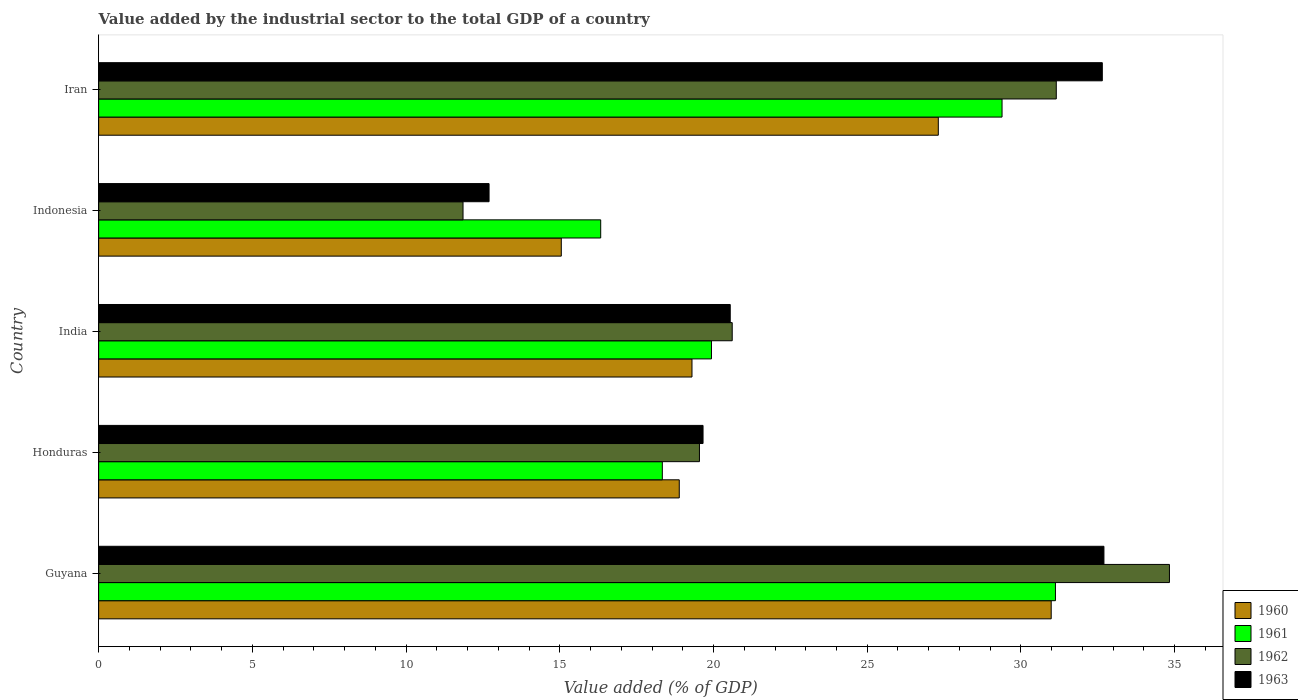How many groups of bars are there?
Ensure brevity in your answer.  5. How many bars are there on the 1st tick from the top?
Give a very brief answer. 4. How many bars are there on the 3rd tick from the bottom?
Keep it short and to the point. 4. What is the label of the 5th group of bars from the top?
Keep it short and to the point. Guyana. In how many cases, is the number of bars for a given country not equal to the number of legend labels?
Keep it short and to the point. 0. What is the value added by the industrial sector to the total GDP in 1960 in Indonesia?
Provide a short and direct response. 15.05. Across all countries, what is the maximum value added by the industrial sector to the total GDP in 1963?
Your answer should be compact. 32.7. Across all countries, what is the minimum value added by the industrial sector to the total GDP in 1960?
Ensure brevity in your answer.  15.05. In which country was the value added by the industrial sector to the total GDP in 1960 maximum?
Keep it short and to the point. Guyana. In which country was the value added by the industrial sector to the total GDP in 1963 minimum?
Make the answer very short. Indonesia. What is the total value added by the industrial sector to the total GDP in 1961 in the graph?
Keep it short and to the point. 115.11. What is the difference between the value added by the industrial sector to the total GDP in 1961 in Guyana and that in Iran?
Ensure brevity in your answer.  1.74. What is the difference between the value added by the industrial sector to the total GDP in 1960 in Honduras and the value added by the industrial sector to the total GDP in 1961 in Iran?
Make the answer very short. -10.5. What is the average value added by the industrial sector to the total GDP in 1963 per country?
Your answer should be compact. 23.65. What is the difference between the value added by the industrial sector to the total GDP in 1962 and value added by the industrial sector to the total GDP in 1960 in Indonesia?
Your response must be concise. -3.2. In how many countries, is the value added by the industrial sector to the total GDP in 1962 greater than 6 %?
Give a very brief answer. 5. What is the ratio of the value added by the industrial sector to the total GDP in 1963 in Honduras to that in India?
Your response must be concise. 0.96. Is the value added by the industrial sector to the total GDP in 1962 in Guyana less than that in Iran?
Ensure brevity in your answer.  No. What is the difference between the highest and the second highest value added by the industrial sector to the total GDP in 1963?
Offer a terse response. 0.05. What is the difference between the highest and the lowest value added by the industrial sector to the total GDP in 1961?
Offer a terse response. 14.79. Is it the case that in every country, the sum of the value added by the industrial sector to the total GDP in 1960 and value added by the industrial sector to the total GDP in 1963 is greater than the sum of value added by the industrial sector to the total GDP in 1962 and value added by the industrial sector to the total GDP in 1961?
Your answer should be very brief. No. What does the 1st bar from the bottom in Indonesia represents?
Offer a terse response. 1960. Is it the case that in every country, the sum of the value added by the industrial sector to the total GDP in 1962 and value added by the industrial sector to the total GDP in 1961 is greater than the value added by the industrial sector to the total GDP in 1963?
Ensure brevity in your answer.  Yes. Are all the bars in the graph horizontal?
Provide a short and direct response. Yes. How many countries are there in the graph?
Offer a terse response. 5. How many legend labels are there?
Keep it short and to the point. 4. What is the title of the graph?
Ensure brevity in your answer.  Value added by the industrial sector to the total GDP of a country. Does "1968" appear as one of the legend labels in the graph?
Your response must be concise. No. What is the label or title of the X-axis?
Your response must be concise. Value added (% of GDP). What is the label or title of the Y-axis?
Ensure brevity in your answer.  Country. What is the Value added (% of GDP) of 1960 in Guyana?
Your answer should be compact. 30.98. What is the Value added (% of GDP) of 1961 in Guyana?
Your response must be concise. 31.12. What is the Value added (% of GDP) of 1962 in Guyana?
Your response must be concise. 34.83. What is the Value added (% of GDP) of 1963 in Guyana?
Offer a terse response. 32.7. What is the Value added (% of GDP) in 1960 in Honduras?
Give a very brief answer. 18.89. What is the Value added (% of GDP) of 1961 in Honduras?
Your answer should be very brief. 18.33. What is the Value added (% of GDP) of 1962 in Honduras?
Make the answer very short. 19.54. What is the Value added (% of GDP) of 1963 in Honduras?
Your answer should be compact. 19.66. What is the Value added (% of GDP) of 1960 in India?
Provide a short and direct response. 19.3. What is the Value added (% of GDP) in 1961 in India?
Your response must be concise. 19.93. What is the Value added (% of GDP) in 1962 in India?
Ensure brevity in your answer.  20.61. What is the Value added (% of GDP) of 1963 in India?
Offer a very short reply. 20.54. What is the Value added (% of GDP) of 1960 in Indonesia?
Provide a succinct answer. 15.05. What is the Value added (% of GDP) of 1961 in Indonesia?
Offer a terse response. 16.33. What is the Value added (% of GDP) of 1962 in Indonesia?
Offer a very short reply. 11.85. What is the Value added (% of GDP) in 1963 in Indonesia?
Your response must be concise. 12.7. What is the Value added (% of GDP) in 1960 in Iran?
Provide a short and direct response. 27.31. What is the Value added (% of GDP) in 1961 in Iran?
Provide a short and direct response. 29.38. What is the Value added (% of GDP) of 1962 in Iran?
Ensure brevity in your answer.  31.15. What is the Value added (% of GDP) of 1963 in Iran?
Provide a succinct answer. 32.65. Across all countries, what is the maximum Value added (% of GDP) in 1960?
Provide a short and direct response. 30.98. Across all countries, what is the maximum Value added (% of GDP) of 1961?
Your answer should be compact. 31.12. Across all countries, what is the maximum Value added (% of GDP) in 1962?
Your response must be concise. 34.83. Across all countries, what is the maximum Value added (% of GDP) of 1963?
Provide a short and direct response. 32.7. Across all countries, what is the minimum Value added (% of GDP) of 1960?
Provide a succinct answer. 15.05. Across all countries, what is the minimum Value added (% of GDP) of 1961?
Make the answer very short. 16.33. Across all countries, what is the minimum Value added (% of GDP) in 1962?
Make the answer very short. 11.85. Across all countries, what is the minimum Value added (% of GDP) in 1963?
Provide a succinct answer. 12.7. What is the total Value added (% of GDP) in 1960 in the graph?
Keep it short and to the point. 111.53. What is the total Value added (% of GDP) of 1961 in the graph?
Your answer should be very brief. 115.11. What is the total Value added (% of GDP) in 1962 in the graph?
Provide a short and direct response. 117.98. What is the total Value added (% of GDP) of 1963 in the graph?
Your response must be concise. 118.25. What is the difference between the Value added (% of GDP) in 1960 in Guyana and that in Honduras?
Your answer should be very brief. 12.1. What is the difference between the Value added (% of GDP) in 1961 in Guyana and that in Honduras?
Your answer should be compact. 12.79. What is the difference between the Value added (% of GDP) of 1962 in Guyana and that in Honduras?
Keep it short and to the point. 15.29. What is the difference between the Value added (% of GDP) in 1963 in Guyana and that in Honduras?
Provide a short and direct response. 13.04. What is the difference between the Value added (% of GDP) in 1960 in Guyana and that in India?
Offer a terse response. 11.68. What is the difference between the Value added (% of GDP) in 1961 in Guyana and that in India?
Offer a terse response. 11.19. What is the difference between the Value added (% of GDP) of 1962 in Guyana and that in India?
Keep it short and to the point. 14.22. What is the difference between the Value added (% of GDP) in 1963 in Guyana and that in India?
Your answer should be very brief. 12.15. What is the difference between the Value added (% of GDP) in 1960 in Guyana and that in Indonesia?
Offer a terse response. 15.93. What is the difference between the Value added (% of GDP) in 1961 in Guyana and that in Indonesia?
Offer a very short reply. 14.79. What is the difference between the Value added (% of GDP) in 1962 in Guyana and that in Indonesia?
Your answer should be very brief. 22.98. What is the difference between the Value added (% of GDP) in 1963 in Guyana and that in Indonesia?
Provide a short and direct response. 20. What is the difference between the Value added (% of GDP) in 1960 in Guyana and that in Iran?
Ensure brevity in your answer.  3.67. What is the difference between the Value added (% of GDP) of 1961 in Guyana and that in Iran?
Give a very brief answer. 1.74. What is the difference between the Value added (% of GDP) in 1962 in Guyana and that in Iran?
Your response must be concise. 3.68. What is the difference between the Value added (% of GDP) in 1963 in Guyana and that in Iran?
Provide a short and direct response. 0.05. What is the difference between the Value added (% of GDP) of 1960 in Honduras and that in India?
Make the answer very short. -0.41. What is the difference between the Value added (% of GDP) of 1961 in Honduras and that in India?
Offer a very short reply. -1.6. What is the difference between the Value added (% of GDP) in 1962 in Honduras and that in India?
Your response must be concise. -1.07. What is the difference between the Value added (% of GDP) of 1963 in Honduras and that in India?
Your answer should be very brief. -0.88. What is the difference between the Value added (% of GDP) of 1960 in Honduras and that in Indonesia?
Make the answer very short. 3.84. What is the difference between the Value added (% of GDP) of 1961 in Honduras and that in Indonesia?
Provide a succinct answer. 2. What is the difference between the Value added (% of GDP) in 1962 in Honduras and that in Indonesia?
Make the answer very short. 7.69. What is the difference between the Value added (% of GDP) in 1963 in Honduras and that in Indonesia?
Provide a short and direct response. 6.96. What is the difference between the Value added (% of GDP) of 1960 in Honduras and that in Iran?
Offer a very short reply. -8.43. What is the difference between the Value added (% of GDP) of 1961 in Honduras and that in Iran?
Your answer should be very brief. -11.05. What is the difference between the Value added (% of GDP) of 1962 in Honduras and that in Iran?
Your answer should be compact. -11.61. What is the difference between the Value added (% of GDP) of 1963 in Honduras and that in Iran?
Offer a terse response. -12.99. What is the difference between the Value added (% of GDP) of 1960 in India and that in Indonesia?
Offer a very short reply. 4.25. What is the difference between the Value added (% of GDP) of 1961 in India and that in Indonesia?
Keep it short and to the point. 3.6. What is the difference between the Value added (% of GDP) in 1962 in India and that in Indonesia?
Offer a terse response. 8.76. What is the difference between the Value added (% of GDP) in 1963 in India and that in Indonesia?
Give a very brief answer. 7.84. What is the difference between the Value added (% of GDP) of 1960 in India and that in Iran?
Make the answer very short. -8.01. What is the difference between the Value added (% of GDP) in 1961 in India and that in Iran?
Your answer should be very brief. -9.45. What is the difference between the Value added (% of GDP) in 1962 in India and that in Iran?
Your answer should be very brief. -10.54. What is the difference between the Value added (% of GDP) of 1963 in India and that in Iran?
Provide a succinct answer. -12.1. What is the difference between the Value added (% of GDP) of 1960 in Indonesia and that in Iran?
Keep it short and to the point. -12.26. What is the difference between the Value added (% of GDP) in 1961 in Indonesia and that in Iran?
Ensure brevity in your answer.  -13.05. What is the difference between the Value added (% of GDP) in 1962 in Indonesia and that in Iran?
Your response must be concise. -19.3. What is the difference between the Value added (% of GDP) in 1963 in Indonesia and that in Iran?
Provide a succinct answer. -19.95. What is the difference between the Value added (% of GDP) of 1960 in Guyana and the Value added (% of GDP) of 1961 in Honduras?
Keep it short and to the point. 12.65. What is the difference between the Value added (% of GDP) of 1960 in Guyana and the Value added (% of GDP) of 1962 in Honduras?
Your answer should be very brief. 11.44. What is the difference between the Value added (% of GDP) of 1960 in Guyana and the Value added (% of GDP) of 1963 in Honduras?
Provide a short and direct response. 11.32. What is the difference between the Value added (% of GDP) in 1961 in Guyana and the Value added (% of GDP) in 1962 in Honduras?
Offer a very short reply. 11.58. What is the difference between the Value added (% of GDP) in 1961 in Guyana and the Value added (% of GDP) in 1963 in Honduras?
Your response must be concise. 11.46. What is the difference between the Value added (% of GDP) of 1962 in Guyana and the Value added (% of GDP) of 1963 in Honduras?
Give a very brief answer. 15.17. What is the difference between the Value added (% of GDP) of 1960 in Guyana and the Value added (% of GDP) of 1961 in India?
Your answer should be compact. 11.05. What is the difference between the Value added (% of GDP) of 1960 in Guyana and the Value added (% of GDP) of 1962 in India?
Ensure brevity in your answer.  10.37. What is the difference between the Value added (% of GDP) of 1960 in Guyana and the Value added (% of GDP) of 1963 in India?
Your response must be concise. 10.44. What is the difference between the Value added (% of GDP) of 1961 in Guyana and the Value added (% of GDP) of 1962 in India?
Give a very brief answer. 10.51. What is the difference between the Value added (% of GDP) of 1961 in Guyana and the Value added (% of GDP) of 1963 in India?
Provide a short and direct response. 10.58. What is the difference between the Value added (% of GDP) in 1962 in Guyana and the Value added (% of GDP) in 1963 in India?
Your answer should be very brief. 14.29. What is the difference between the Value added (% of GDP) in 1960 in Guyana and the Value added (% of GDP) in 1961 in Indonesia?
Provide a succinct answer. 14.65. What is the difference between the Value added (% of GDP) in 1960 in Guyana and the Value added (% of GDP) in 1962 in Indonesia?
Provide a succinct answer. 19.13. What is the difference between the Value added (% of GDP) of 1960 in Guyana and the Value added (% of GDP) of 1963 in Indonesia?
Your answer should be very brief. 18.28. What is the difference between the Value added (% of GDP) in 1961 in Guyana and the Value added (% of GDP) in 1962 in Indonesia?
Ensure brevity in your answer.  19.27. What is the difference between the Value added (% of GDP) in 1961 in Guyana and the Value added (% of GDP) in 1963 in Indonesia?
Give a very brief answer. 18.42. What is the difference between the Value added (% of GDP) of 1962 in Guyana and the Value added (% of GDP) of 1963 in Indonesia?
Your answer should be very brief. 22.13. What is the difference between the Value added (% of GDP) of 1960 in Guyana and the Value added (% of GDP) of 1961 in Iran?
Give a very brief answer. 1.6. What is the difference between the Value added (% of GDP) in 1960 in Guyana and the Value added (% of GDP) in 1962 in Iran?
Provide a succinct answer. -0.17. What is the difference between the Value added (% of GDP) in 1960 in Guyana and the Value added (% of GDP) in 1963 in Iran?
Ensure brevity in your answer.  -1.66. What is the difference between the Value added (% of GDP) of 1961 in Guyana and the Value added (% of GDP) of 1962 in Iran?
Provide a succinct answer. -0.03. What is the difference between the Value added (% of GDP) in 1961 in Guyana and the Value added (% of GDP) in 1963 in Iran?
Provide a short and direct response. -1.52. What is the difference between the Value added (% of GDP) of 1962 in Guyana and the Value added (% of GDP) of 1963 in Iran?
Ensure brevity in your answer.  2.18. What is the difference between the Value added (% of GDP) of 1960 in Honduras and the Value added (% of GDP) of 1961 in India?
Offer a terse response. -1.05. What is the difference between the Value added (% of GDP) of 1960 in Honduras and the Value added (% of GDP) of 1962 in India?
Make the answer very short. -1.72. What is the difference between the Value added (% of GDP) in 1960 in Honduras and the Value added (% of GDP) in 1963 in India?
Keep it short and to the point. -1.66. What is the difference between the Value added (% of GDP) of 1961 in Honduras and the Value added (% of GDP) of 1962 in India?
Offer a very short reply. -2.27. What is the difference between the Value added (% of GDP) of 1961 in Honduras and the Value added (% of GDP) of 1963 in India?
Provide a succinct answer. -2.21. What is the difference between the Value added (% of GDP) of 1962 in Honduras and the Value added (% of GDP) of 1963 in India?
Provide a succinct answer. -1. What is the difference between the Value added (% of GDP) in 1960 in Honduras and the Value added (% of GDP) in 1961 in Indonesia?
Provide a short and direct response. 2.56. What is the difference between the Value added (% of GDP) in 1960 in Honduras and the Value added (% of GDP) in 1962 in Indonesia?
Your answer should be compact. 7.03. What is the difference between the Value added (% of GDP) of 1960 in Honduras and the Value added (% of GDP) of 1963 in Indonesia?
Provide a succinct answer. 6.19. What is the difference between the Value added (% of GDP) in 1961 in Honduras and the Value added (% of GDP) in 1962 in Indonesia?
Keep it short and to the point. 6.48. What is the difference between the Value added (% of GDP) of 1961 in Honduras and the Value added (% of GDP) of 1963 in Indonesia?
Keep it short and to the point. 5.64. What is the difference between the Value added (% of GDP) in 1962 in Honduras and the Value added (% of GDP) in 1963 in Indonesia?
Provide a succinct answer. 6.84. What is the difference between the Value added (% of GDP) in 1960 in Honduras and the Value added (% of GDP) in 1961 in Iran?
Keep it short and to the point. -10.5. What is the difference between the Value added (% of GDP) of 1960 in Honduras and the Value added (% of GDP) of 1962 in Iran?
Provide a succinct answer. -12.26. What is the difference between the Value added (% of GDP) in 1960 in Honduras and the Value added (% of GDP) in 1963 in Iran?
Provide a short and direct response. -13.76. What is the difference between the Value added (% of GDP) in 1961 in Honduras and the Value added (% of GDP) in 1962 in Iran?
Provide a short and direct response. -12.81. What is the difference between the Value added (% of GDP) in 1961 in Honduras and the Value added (% of GDP) in 1963 in Iran?
Your response must be concise. -14.31. What is the difference between the Value added (% of GDP) of 1962 in Honduras and the Value added (% of GDP) of 1963 in Iran?
Make the answer very short. -13.1. What is the difference between the Value added (% of GDP) in 1960 in India and the Value added (% of GDP) in 1961 in Indonesia?
Offer a terse response. 2.97. What is the difference between the Value added (% of GDP) of 1960 in India and the Value added (% of GDP) of 1962 in Indonesia?
Your answer should be compact. 7.45. What is the difference between the Value added (% of GDP) in 1960 in India and the Value added (% of GDP) in 1963 in Indonesia?
Provide a short and direct response. 6.6. What is the difference between the Value added (% of GDP) in 1961 in India and the Value added (% of GDP) in 1962 in Indonesia?
Your response must be concise. 8.08. What is the difference between the Value added (% of GDP) in 1961 in India and the Value added (% of GDP) in 1963 in Indonesia?
Give a very brief answer. 7.23. What is the difference between the Value added (% of GDP) in 1962 in India and the Value added (% of GDP) in 1963 in Indonesia?
Offer a very short reply. 7.91. What is the difference between the Value added (% of GDP) in 1960 in India and the Value added (% of GDP) in 1961 in Iran?
Your response must be concise. -10.09. What is the difference between the Value added (% of GDP) in 1960 in India and the Value added (% of GDP) in 1962 in Iran?
Your response must be concise. -11.85. What is the difference between the Value added (% of GDP) of 1960 in India and the Value added (% of GDP) of 1963 in Iran?
Your answer should be very brief. -13.35. What is the difference between the Value added (% of GDP) of 1961 in India and the Value added (% of GDP) of 1962 in Iran?
Ensure brevity in your answer.  -11.22. What is the difference between the Value added (% of GDP) of 1961 in India and the Value added (% of GDP) of 1963 in Iran?
Your answer should be very brief. -12.71. What is the difference between the Value added (% of GDP) in 1962 in India and the Value added (% of GDP) in 1963 in Iran?
Your response must be concise. -12.04. What is the difference between the Value added (% of GDP) of 1960 in Indonesia and the Value added (% of GDP) of 1961 in Iran?
Your response must be concise. -14.34. What is the difference between the Value added (% of GDP) in 1960 in Indonesia and the Value added (% of GDP) in 1962 in Iran?
Provide a short and direct response. -16.1. What is the difference between the Value added (% of GDP) of 1960 in Indonesia and the Value added (% of GDP) of 1963 in Iran?
Offer a terse response. -17.6. What is the difference between the Value added (% of GDP) of 1961 in Indonesia and the Value added (% of GDP) of 1962 in Iran?
Your answer should be compact. -14.82. What is the difference between the Value added (% of GDP) of 1961 in Indonesia and the Value added (% of GDP) of 1963 in Iran?
Provide a succinct answer. -16.32. What is the difference between the Value added (% of GDP) of 1962 in Indonesia and the Value added (% of GDP) of 1963 in Iran?
Provide a short and direct response. -20.79. What is the average Value added (% of GDP) in 1960 per country?
Your response must be concise. 22.31. What is the average Value added (% of GDP) in 1961 per country?
Give a very brief answer. 23.02. What is the average Value added (% of GDP) in 1962 per country?
Ensure brevity in your answer.  23.6. What is the average Value added (% of GDP) of 1963 per country?
Give a very brief answer. 23.65. What is the difference between the Value added (% of GDP) in 1960 and Value added (% of GDP) in 1961 in Guyana?
Your answer should be very brief. -0.14. What is the difference between the Value added (% of GDP) in 1960 and Value added (% of GDP) in 1962 in Guyana?
Keep it short and to the point. -3.85. What is the difference between the Value added (% of GDP) of 1960 and Value added (% of GDP) of 1963 in Guyana?
Make the answer very short. -1.72. What is the difference between the Value added (% of GDP) in 1961 and Value added (% of GDP) in 1962 in Guyana?
Ensure brevity in your answer.  -3.71. What is the difference between the Value added (% of GDP) in 1961 and Value added (% of GDP) in 1963 in Guyana?
Offer a terse response. -1.58. What is the difference between the Value added (% of GDP) in 1962 and Value added (% of GDP) in 1963 in Guyana?
Provide a short and direct response. 2.13. What is the difference between the Value added (% of GDP) in 1960 and Value added (% of GDP) in 1961 in Honduras?
Make the answer very short. 0.55. What is the difference between the Value added (% of GDP) in 1960 and Value added (% of GDP) in 1962 in Honduras?
Give a very brief answer. -0.66. What is the difference between the Value added (% of GDP) in 1960 and Value added (% of GDP) in 1963 in Honduras?
Ensure brevity in your answer.  -0.77. What is the difference between the Value added (% of GDP) in 1961 and Value added (% of GDP) in 1962 in Honduras?
Ensure brevity in your answer.  -1.21. What is the difference between the Value added (% of GDP) of 1961 and Value added (% of GDP) of 1963 in Honduras?
Provide a short and direct response. -1.32. What is the difference between the Value added (% of GDP) in 1962 and Value added (% of GDP) in 1963 in Honduras?
Your answer should be very brief. -0.12. What is the difference between the Value added (% of GDP) of 1960 and Value added (% of GDP) of 1961 in India?
Ensure brevity in your answer.  -0.63. What is the difference between the Value added (% of GDP) in 1960 and Value added (% of GDP) in 1962 in India?
Offer a very short reply. -1.31. What is the difference between the Value added (% of GDP) in 1960 and Value added (% of GDP) in 1963 in India?
Ensure brevity in your answer.  -1.24. What is the difference between the Value added (% of GDP) in 1961 and Value added (% of GDP) in 1962 in India?
Give a very brief answer. -0.68. What is the difference between the Value added (% of GDP) of 1961 and Value added (% of GDP) of 1963 in India?
Provide a short and direct response. -0.61. What is the difference between the Value added (% of GDP) in 1962 and Value added (% of GDP) in 1963 in India?
Offer a terse response. 0.06. What is the difference between the Value added (% of GDP) in 1960 and Value added (% of GDP) in 1961 in Indonesia?
Make the answer very short. -1.28. What is the difference between the Value added (% of GDP) of 1960 and Value added (% of GDP) of 1962 in Indonesia?
Provide a short and direct response. 3.2. What is the difference between the Value added (% of GDP) of 1960 and Value added (% of GDP) of 1963 in Indonesia?
Your answer should be compact. 2.35. What is the difference between the Value added (% of GDP) of 1961 and Value added (% of GDP) of 1962 in Indonesia?
Make the answer very short. 4.48. What is the difference between the Value added (% of GDP) in 1961 and Value added (% of GDP) in 1963 in Indonesia?
Your response must be concise. 3.63. What is the difference between the Value added (% of GDP) of 1962 and Value added (% of GDP) of 1963 in Indonesia?
Make the answer very short. -0.85. What is the difference between the Value added (% of GDP) of 1960 and Value added (% of GDP) of 1961 in Iran?
Your answer should be very brief. -2.07. What is the difference between the Value added (% of GDP) in 1960 and Value added (% of GDP) in 1962 in Iran?
Your answer should be compact. -3.84. What is the difference between the Value added (% of GDP) in 1960 and Value added (% of GDP) in 1963 in Iran?
Your answer should be compact. -5.33. What is the difference between the Value added (% of GDP) of 1961 and Value added (% of GDP) of 1962 in Iran?
Give a very brief answer. -1.76. What is the difference between the Value added (% of GDP) in 1961 and Value added (% of GDP) in 1963 in Iran?
Your answer should be compact. -3.26. What is the difference between the Value added (% of GDP) of 1962 and Value added (% of GDP) of 1963 in Iran?
Your answer should be compact. -1.5. What is the ratio of the Value added (% of GDP) in 1960 in Guyana to that in Honduras?
Give a very brief answer. 1.64. What is the ratio of the Value added (% of GDP) in 1961 in Guyana to that in Honduras?
Provide a short and direct response. 1.7. What is the ratio of the Value added (% of GDP) in 1962 in Guyana to that in Honduras?
Offer a very short reply. 1.78. What is the ratio of the Value added (% of GDP) in 1963 in Guyana to that in Honduras?
Give a very brief answer. 1.66. What is the ratio of the Value added (% of GDP) of 1960 in Guyana to that in India?
Keep it short and to the point. 1.61. What is the ratio of the Value added (% of GDP) in 1961 in Guyana to that in India?
Provide a short and direct response. 1.56. What is the ratio of the Value added (% of GDP) in 1962 in Guyana to that in India?
Offer a terse response. 1.69. What is the ratio of the Value added (% of GDP) in 1963 in Guyana to that in India?
Provide a short and direct response. 1.59. What is the ratio of the Value added (% of GDP) of 1960 in Guyana to that in Indonesia?
Your response must be concise. 2.06. What is the ratio of the Value added (% of GDP) in 1961 in Guyana to that in Indonesia?
Provide a succinct answer. 1.91. What is the ratio of the Value added (% of GDP) of 1962 in Guyana to that in Indonesia?
Keep it short and to the point. 2.94. What is the ratio of the Value added (% of GDP) in 1963 in Guyana to that in Indonesia?
Provide a short and direct response. 2.57. What is the ratio of the Value added (% of GDP) of 1960 in Guyana to that in Iran?
Offer a terse response. 1.13. What is the ratio of the Value added (% of GDP) in 1961 in Guyana to that in Iran?
Provide a succinct answer. 1.06. What is the ratio of the Value added (% of GDP) of 1962 in Guyana to that in Iran?
Provide a short and direct response. 1.12. What is the ratio of the Value added (% of GDP) in 1963 in Guyana to that in Iran?
Provide a short and direct response. 1. What is the ratio of the Value added (% of GDP) in 1960 in Honduras to that in India?
Ensure brevity in your answer.  0.98. What is the ratio of the Value added (% of GDP) in 1961 in Honduras to that in India?
Offer a very short reply. 0.92. What is the ratio of the Value added (% of GDP) of 1962 in Honduras to that in India?
Provide a short and direct response. 0.95. What is the ratio of the Value added (% of GDP) of 1963 in Honduras to that in India?
Your response must be concise. 0.96. What is the ratio of the Value added (% of GDP) of 1960 in Honduras to that in Indonesia?
Keep it short and to the point. 1.25. What is the ratio of the Value added (% of GDP) of 1961 in Honduras to that in Indonesia?
Your response must be concise. 1.12. What is the ratio of the Value added (% of GDP) of 1962 in Honduras to that in Indonesia?
Your response must be concise. 1.65. What is the ratio of the Value added (% of GDP) of 1963 in Honduras to that in Indonesia?
Offer a terse response. 1.55. What is the ratio of the Value added (% of GDP) of 1960 in Honduras to that in Iran?
Provide a short and direct response. 0.69. What is the ratio of the Value added (% of GDP) of 1961 in Honduras to that in Iran?
Your response must be concise. 0.62. What is the ratio of the Value added (% of GDP) in 1962 in Honduras to that in Iran?
Give a very brief answer. 0.63. What is the ratio of the Value added (% of GDP) in 1963 in Honduras to that in Iran?
Your answer should be compact. 0.6. What is the ratio of the Value added (% of GDP) in 1960 in India to that in Indonesia?
Offer a terse response. 1.28. What is the ratio of the Value added (% of GDP) in 1961 in India to that in Indonesia?
Your answer should be compact. 1.22. What is the ratio of the Value added (% of GDP) of 1962 in India to that in Indonesia?
Provide a succinct answer. 1.74. What is the ratio of the Value added (% of GDP) in 1963 in India to that in Indonesia?
Ensure brevity in your answer.  1.62. What is the ratio of the Value added (% of GDP) in 1960 in India to that in Iran?
Your answer should be very brief. 0.71. What is the ratio of the Value added (% of GDP) of 1961 in India to that in Iran?
Offer a very short reply. 0.68. What is the ratio of the Value added (% of GDP) of 1962 in India to that in Iran?
Provide a short and direct response. 0.66. What is the ratio of the Value added (% of GDP) in 1963 in India to that in Iran?
Make the answer very short. 0.63. What is the ratio of the Value added (% of GDP) in 1960 in Indonesia to that in Iran?
Provide a short and direct response. 0.55. What is the ratio of the Value added (% of GDP) of 1961 in Indonesia to that in Iran?
Keep it short and to the point. 0.56. What is the ratio of the Value added (% of GDP) in 1962 in Indonesia to that in Iran?
Offer a terse response. 0.38. What is the ratio of the Value added (% of GDP) of 1963 in Indonesia to that in Iran?
Your answer should be very brief. 0.39. What is the difference between the highest and the second highest Value added (% of GDP) of 1960?
Ensure brevity in your answer.  3.67. What is the difference between the highest and the second highest Value added (% of GDP) in 1961?
Your answer should be very brief. 1.74. What is the difference between the highest and the second highest Value added (% of GDP) in 1962?
Provide a succinct answer. 3.68. What is the difference between the highest and the second highest Value added (% of GDP) in 1963?
Give a very brief answer. 0.05. What is the difference between the highest and the lowest Value added (% of GDP) of 1960?
Your answer should be very brief. 15.93. What is the difference between the highest and the lowest Value added (% of GDP) in 1961?
Ensure brevity in your answer.  14.79. What is the difference between the highest and the lowest Value added (% of GDP) of 1962?
Give a very brief answer. 22.98. What is the difference between the highest and the lowest Value added (% of GDP) of 1963?
Make the answer very short. 20. 